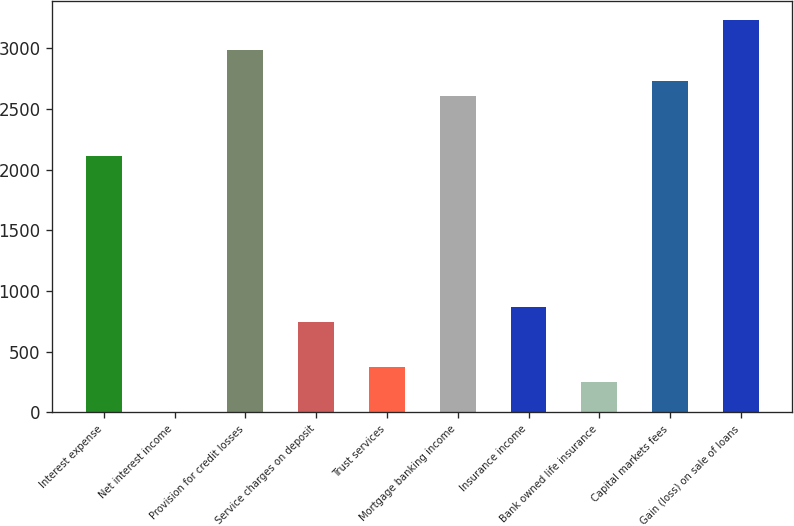Convert chart to OTSL. <chart><loc_0><loc_0><loc_500><loc_500><bar_chart><fcel>Interest expense<fcel>Net interest income<fcel>Provision for credit losses<fcel>Service charges on deposit<fcel>Trust services<fcel>Mortgage banking income<fcel>Insurance income<fcel>Bank owned life insurance<fcel>Capital markets fees<fcel>Gain (loss) on sale of loans<nl><fcel>2112.4<fcel>1<fcel>2981.8<fcel>746.2<fcel>373.6<fcel>2609.2<fcel>870.4<fcel>249.4<fcel>2733.4<fcel>3230.2<nl></chart> 